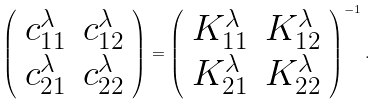Convert formula to latex. <formula><loc_0><loc_0><loc_500><loc_500>\left ( \begin{array} { c c } c ^ { \lambda } _ { 1 1 } & c ^ { \lambda } _ { 1 2 } \\ c ^ { \lambda } _ { 2 1 } & c ^ { \lambda } _ { 2 2 } \end{array} \right ) = \left ( \begin{array} { c c } K ^ { \lambda } _ { 1 1 } & K ^ { \lambda } _ { 1 2 } \\ K ^ { \lambda } _ { 2 1 } & K ^ { \lambda } _ { 2 2 } \end{array} \right ) ^ { - 1 } .</formula> 